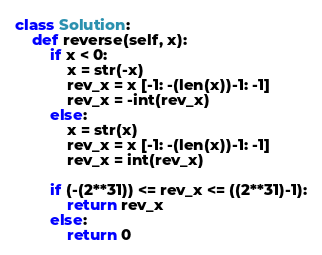<code> <loc_0><loc_0><loc_500><loc_500><_Python_>class Solution:
    def reverse(self, x):
        if x < 0:
            x = str(-x)
            rev_x = x [-1: -(len(x))-1: -1]
            rev_x = -int(rev_x)
        else:
            x = str(x)
            rev_x = x [-1: -(len(x))-1: -1]
            rev_x = int(rev_x)
        
        if (-(2**31)) <= rev_x <= ((2**31)-1):
            return rev_x
        else: 
            return 0</code> 